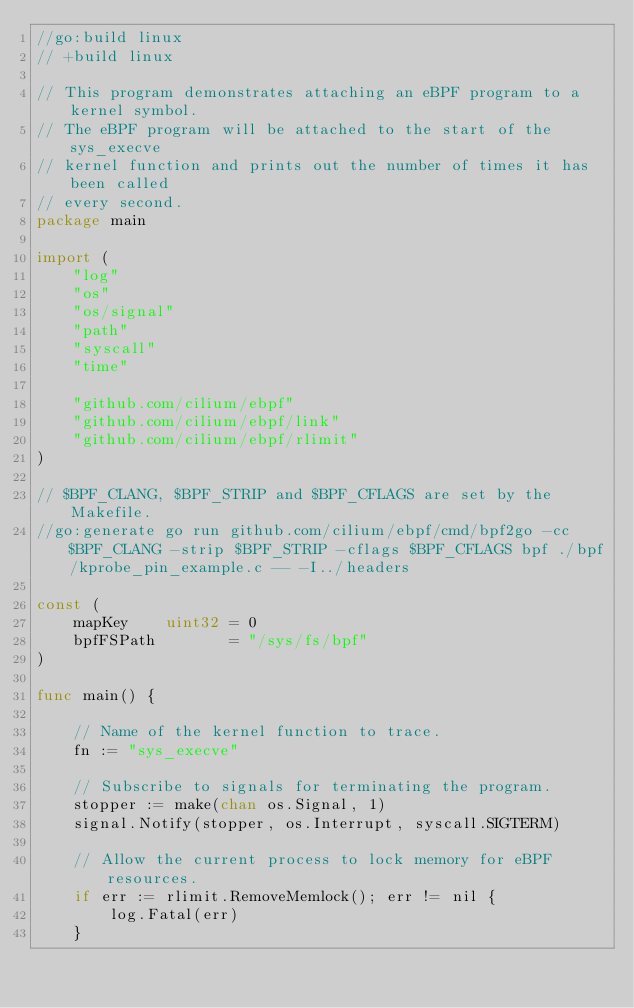Convert code to text. <code><loc_0><loc_0><loc_500><loc_500><_Go_>//go:build linux
// +build linux

// This program demonstrates attaching an eBPF program to a kernel symbol.
// The eBPF program will be attached to the start of the sys_execve
// kernel function and prints out the number of times it has been called
// every second.
package main

import (
	"log"
	"os"
	"os/signal"
	"path"
	"syscall"
	"time"

	"github.com/cilium/ebpf"
	"github.com/cilium/ebpf/link"
	"github.com/cilium/ebpf/rlimit"
)

// $BPF_CLANG, $BPF_STRIP and $BPF_CFLAGS are set by the Makefile.
//go:generate go run github.com/cilium/ebpf/cmd/bpf2go -cc $BPF_CLANG -strip $BPF_STRIP -cflags $BPF_CFLAGS bpf ./bpf/kprobe_pin_example.c -- -I../headers

const (
	mapKey    uint32 = 0
	bpfFSPath        = "/sys/fs/bpf"
)

func main() {

	// Name of the kernel function to trace.
	fn := "sys_execve"

	// Subscribe to signals for terminating the program.
	stopper := make(chan os.Signal, 1)
	signal.Notify(stopper, os.Interrupt, syscall.SIGTERM)

	// Allow the current process to lock memory for eBPF resources.
	if err := rlimit.RemoveMemlock(); err != nil {
		log.Fatal(err)
	}
</code> 